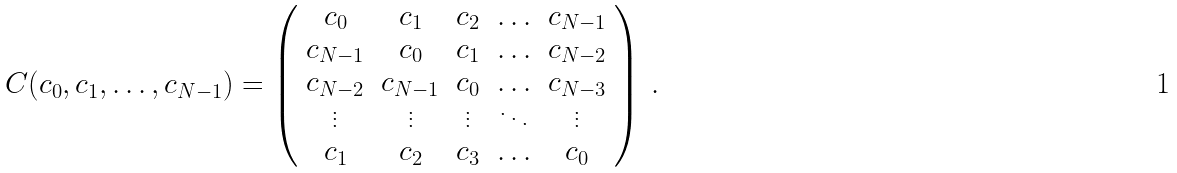Convert formula to latex. <formula><loc_0><loc_0><loc_500><loc_500>C ( c _ { 0 } , c _ { 1 } , \hdots , c _ { N - 1 } ) = \left ( \begin{array} { c c c c c } c _ { 0 } & c _ { 1 } & c _ { 2 } & \hdots & c _ { N - 1 } \\ c _ { N - 1 } & c _ { 0 } & c _ { 1 } & \hdots & c _ { N - 2 } \\ c _ { N - 2 } & c _ { N - 1 } & c _ { 0 } & \hdots & c _ { N - 3 } \\ \vdots & \vdots & \vdots & \ddots & \vdots \\ c _ { 1 } & c _ { 2 } & c _ { 3 } & \hdots & c _ { 0 } \end{array} \right ) \, .</formula> 